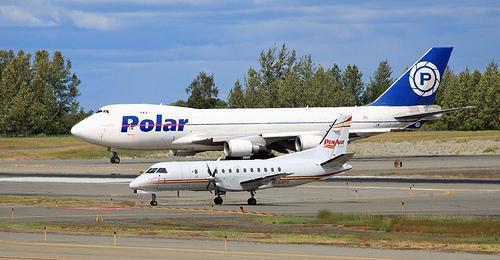How many airplanes have a blue tail?
Give a very brief answer. 1. 